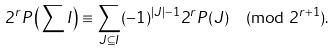Convert formula to latex. <formula><loc_0><loc_0><loc_500><loc_500>2 ^ { r } P \left ( \sum I \right ) \equiv \sum _ { J \subseteq I } ( - 1 ) ^ { | J | - 1 } 2 ^ { r } P ( J ) \pmod { 2 ^ { r + 1 } } .</formula> 